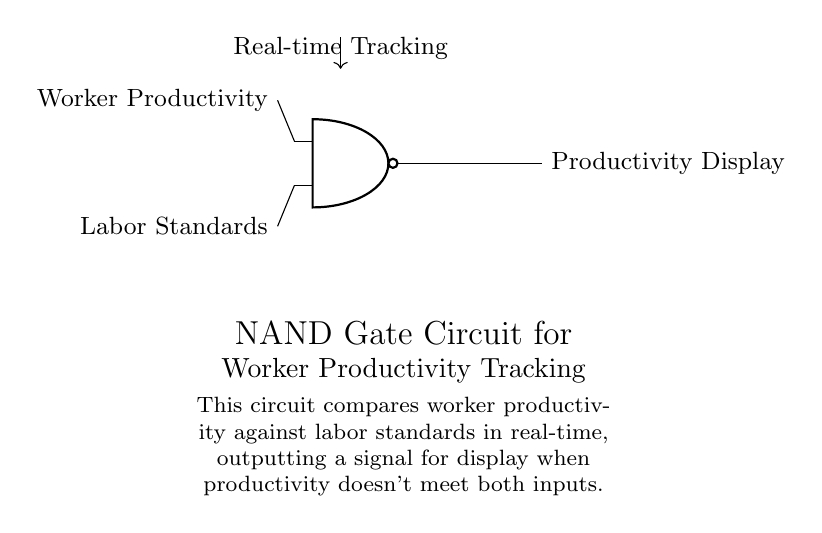What type of gate is this circuit? This circuit is specifically built using a NAND gate, indicated by the shape and label at the center of the diagram.
Answer: NAND gate What are the two inputs of the NAND gate? The inputs are labeled as "Worker Productivity" and "Labor Standards," which are the variables being compared within the circuit.
Answer: Worker Productivity, Labor Standards What does the output represent? The output node labeled "Productivity Display" shows the result of the NAND operation between the two inputs, indicating when productivity is below the labor standards.
Answer: Productivity Display What does the arrow pointing upwards signify? The upward arrow labeled "Real-time Tracking" indicates that there is a continuous monitoring system in place that feeds data into the two inputs for real-time comparison.
Answer: Real-time Tracking What is the logical function performed by the NAND gate? The NAND gate produces an output of true (or high) except in the case where both inputs are true (or high). Therefore, it will only output a signal to the display when productivity does not meet labor standards.
Answer: Non-conjunction What happens to the output if both inputs are high? If both "Worker Productivity" and "Labor Standards" inputs are high, the NAND gate will yield a low output, indicating that productivity meets or exceeds the labor standards, and thus the display will not be activated.
Answer: Low output How does this circuit help in labor rights monitoring? This circuit provides real-time feedback on worker productivity relative to established labor standards, which is essential for ensuring that worker rights are upheld and potential issues can be promptly addressed.
Answer: Real-time monitoring 